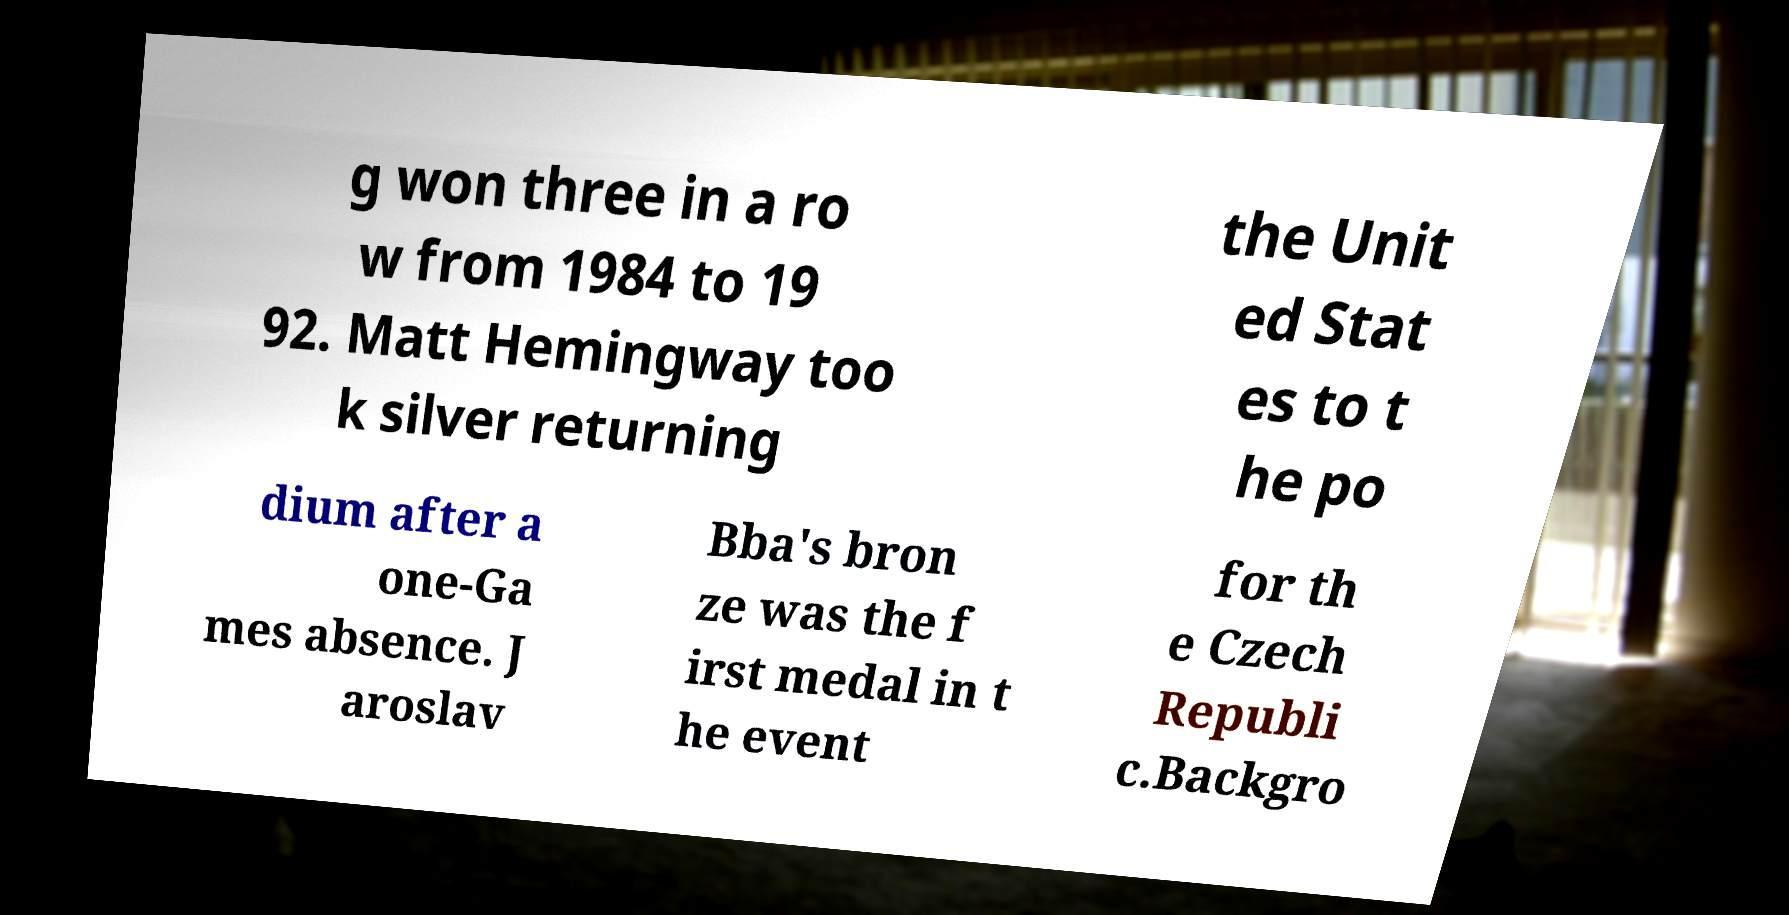Could you extract and type out the text from this image? g won three in a ro w from 1984 to 19 92. Matt Hemingway too k silver returning the Unit ed Stat es to t he po dium after a one-Ga mes absence. J aroslav Bba's bron ze was the f irst medal in t he event for th e Czech Republi c.Backgro 